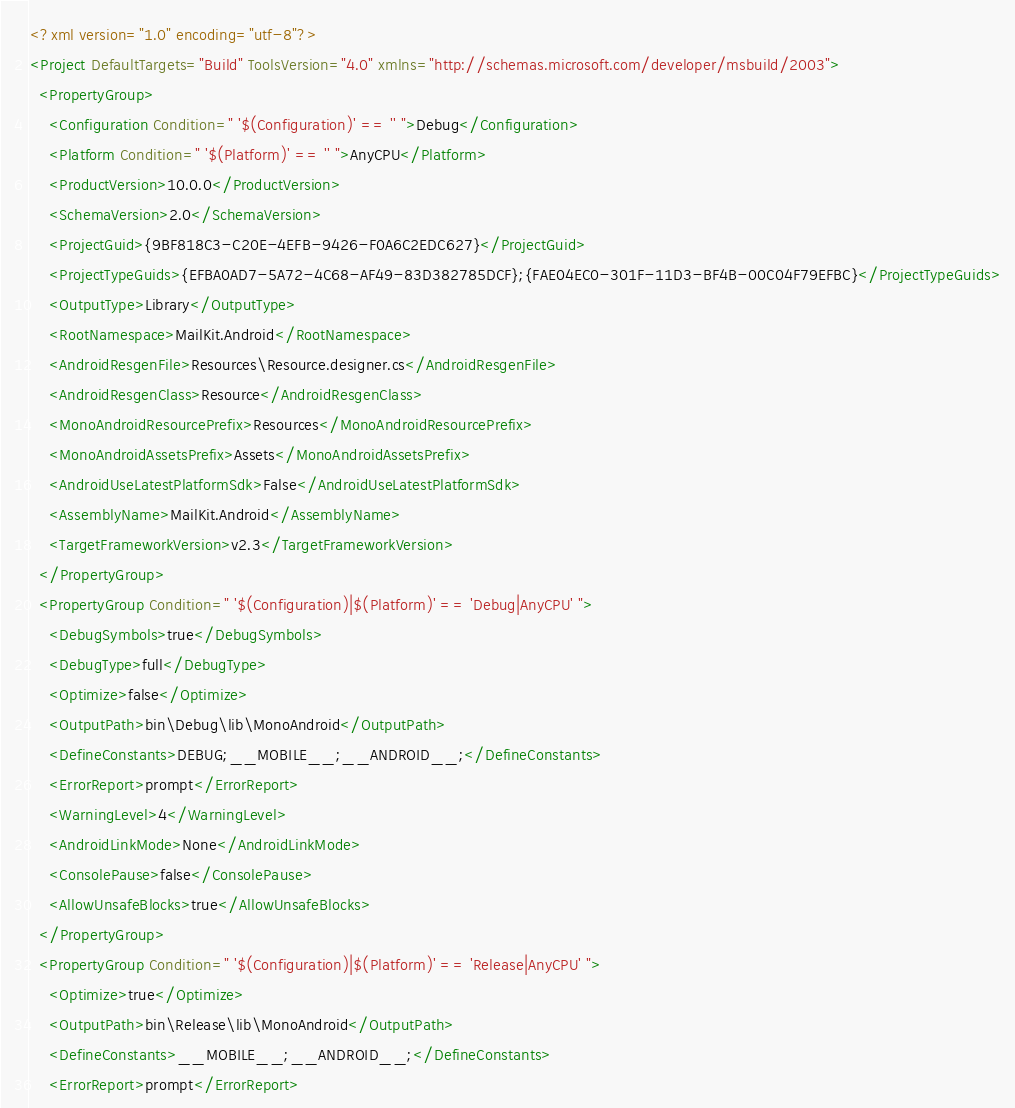Convert code to text. <code><loc_0><loc_0><loc_500><loc_500><_XML_><?xml version="1.0" encoding="utf-8"?>
<Project DefaultTargets="Build" ToolsVersion="4.0" xmlns="http://schemas.microsoft.com/developer/msbuild/2003">
  <PropertyGroup>
    <Configuration Condition=" '$(Configuration)' == '' ">Debug</Configuration>
    <Platform Condition=" '$(Platform)' == '' ">AnyCPU</Platform>
    <ProductVersion>10.0.0</ProductVersion>
    <SchemaVersion>2.0</SchemaVersion>
    <ProjectGuid>{9BF818C3-C20E-4EFB-9426-F0A6C2EDC627}</ProjectGuid>
    <ProjectTypeGuids>{EFBA0AD7-5A72-4C68-AF49-83D382785DCF};{FAE04EC0-301F-11D3-BF4B-00C04F79EFBC}</ProjectTypeGuids>
    <OutputType>Library</OutputType>
    <RootNamespace>MailKit.Android</RootNamespace>
    <AndroidResgenFile>Resources\Resource.designer.cs</AndroidResgenFile>
    <AndroidResgenClass>Resource</AndroidResgenClass>
    <MonoAndroidResourcePrefix>Resources</MonoAndroidResourcePrefix>
    <MonoAndroidAssetsPrefix>Assets</MonoAndroidAssetsPrefix>
    <AndroidUseLatestPlatformSdk>False</AndroidUseLatestPlatformSdk>
    <AssemblyName>MailKit.Android</AssemblyName>
    <TargetFrameworkVersion>v2.3</TargetFrameworkVersion>
  </PropertyGroup>
  <PropertyGroup Condition=" '$(Configuration)|$(Platform)' == 'Debug|AnyCPU' ">
    <DebugSymbols>true</DebugSymbols>
    <DebugType>full</DebugType>
    <Optimize>false</Optimize>
    <OutputPath>bin\Debug\lib\MonoAndroid</OutputPath>
    <DefineConstants>DEBUG;__MOBILE__;__ANDROID__;</DefineConstants>
    <ErrorReport>prompt</ErrorReport>
    <WarningLevel>4</WarningLevel>
    <AndroidLinkMode>None</AndroidLinkMode>
    <ConsolePause>false</ConsolePause>
    <AllowUnsafeBlocks>true</AllowUnsafeBlocks>
  </PropertyGroup>
  <PropertyGroup Condition=" '$(Configuration)|$(Platform)' == 'Release|AnyCPU' ">
    <Optimize>true</Optimize>
    <OutputPath>bin\Release\lib\MonoAndroid</OutputPath>
    <DefineConstants>__MOBILE__;__ANDROID__;</DefineConstants>
    <ErrorReport>prompt</ErrorReport></code> 